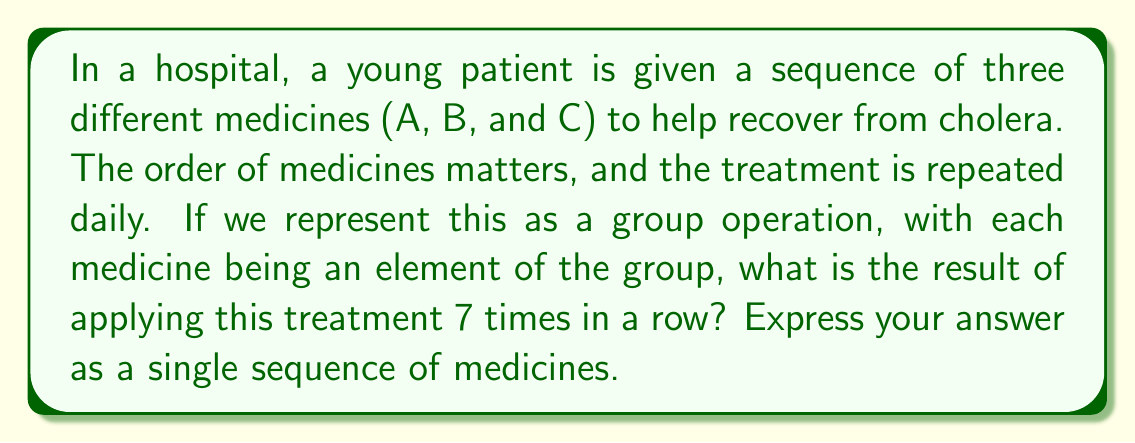Teach me how to tackle this problem. Let's approach this step-by-step:

1) First, we need to understand what the group operation represents. In this case, it's the sequence of medicines given in one day: A, then B, then C. Let's call this sequence S.

2) So, S = ABC

3) Now, we need to apply this sequence 7 times. In group theory notation, this would be written as $S^7$.

4) Let's see what happens when we apply S multiple times:

   $S^1 = ABC$
   $S^2 = (ABC)(ABC) = ABCABC$
   $S^3 = (ABC)(ABC)(ABC) = ABCABCABC$

5) We can see a pattern forming. Each application of S adds ABC to the end of the sequence.

6) Therefore, $S^7$ would be:

   $S^7 = \underbrace{ABCABCABC...ABC}_{7 \text{ times}}$

7) To count the total number of medicines given, we can multiply:
   7 (applications) × 3 (medicines per application) = 21 medicines total

8) The sequence will be ABC repeated 7 times.
Answer: ABCABCABCABCABCABCABC 